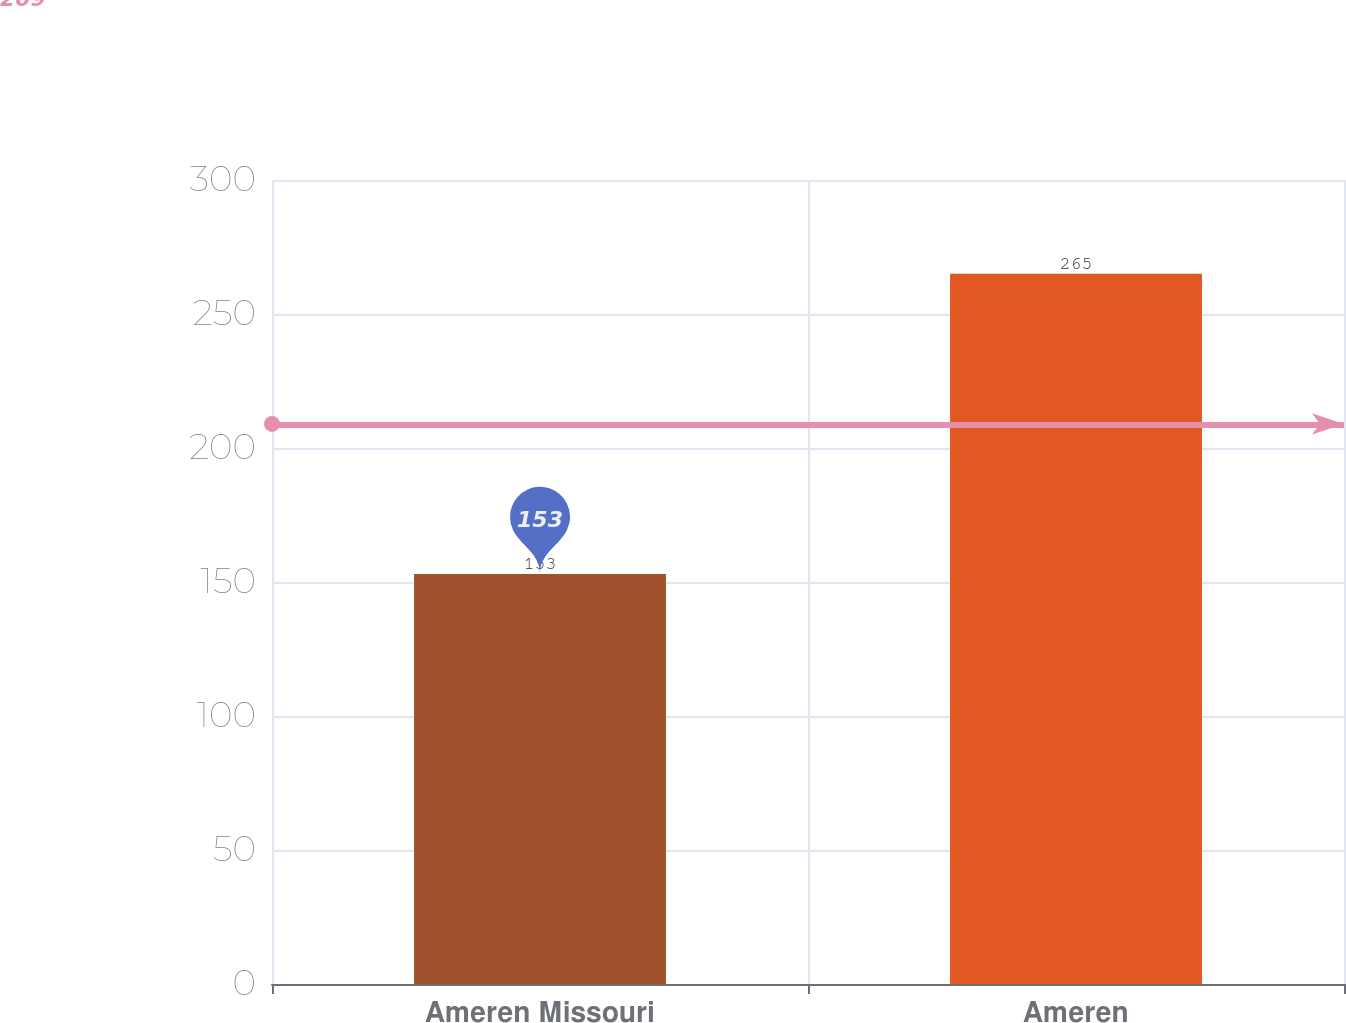<chart> <loc_0><loc_0><loc_500><loc_500><bar_chart><fcel>Ameren Missouri<fcel>Ameren<nl><fcel>153<fcel>265<nl></chart> 